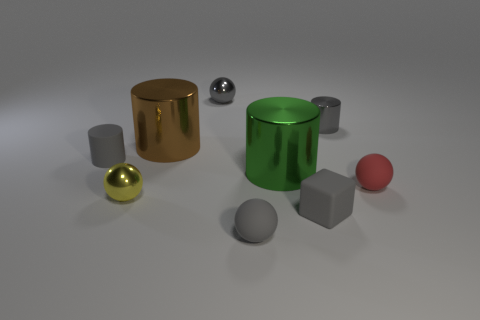The shiny object that is the same color as the small metallic cylinder is what shape?
Your answer should be very brief. Sphere. Is there any other thing that has the same color as the tiny cube?
Offer a very short reply. Yes. What number of other things are there of the same size as the matte cylinder?
Ensure brevity in your answer.  6. How many metal objects are either small gray cylinders or red objects?
Offer a terse response. 1. Is the shape of the small rubber thing that is on the left side of the large brown thing the same as the tiny gray metallic object right of the tiny gray cube?
Your answer should be compact. Yes. Is there another tiny thing that has the same material as the brown object?
Your answer should be compact. Yes. What is the color of the small matte block?
Provide a short and direct response. Gray. There is a shiny object in front of the red object; what size is it?
Offer a terse response. Small. What number of cylinders are the same color as the small rubber cube?
Ensure brevity in your answer.  2. Are there any small objects that are in front of the gray cylinder in front of the large brown thing?
Offer a very short reply. Yes. 